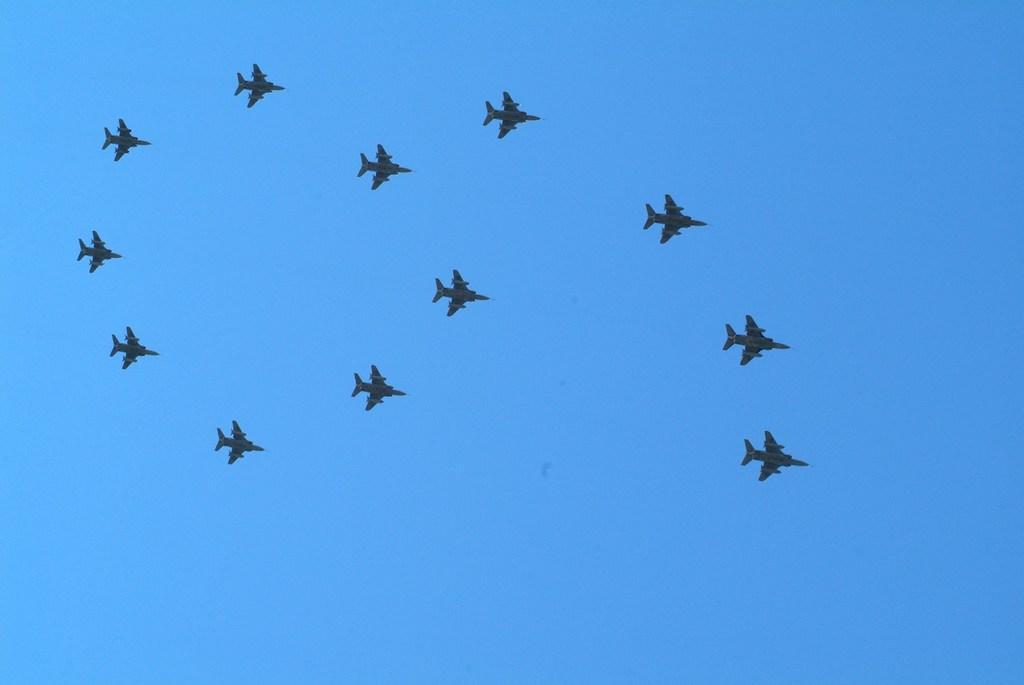In one or two sentences, can you explain what this image depicts? In this image, we can see there are aircraft, flying in the air. In the background, there are clouds in the blue sky. 